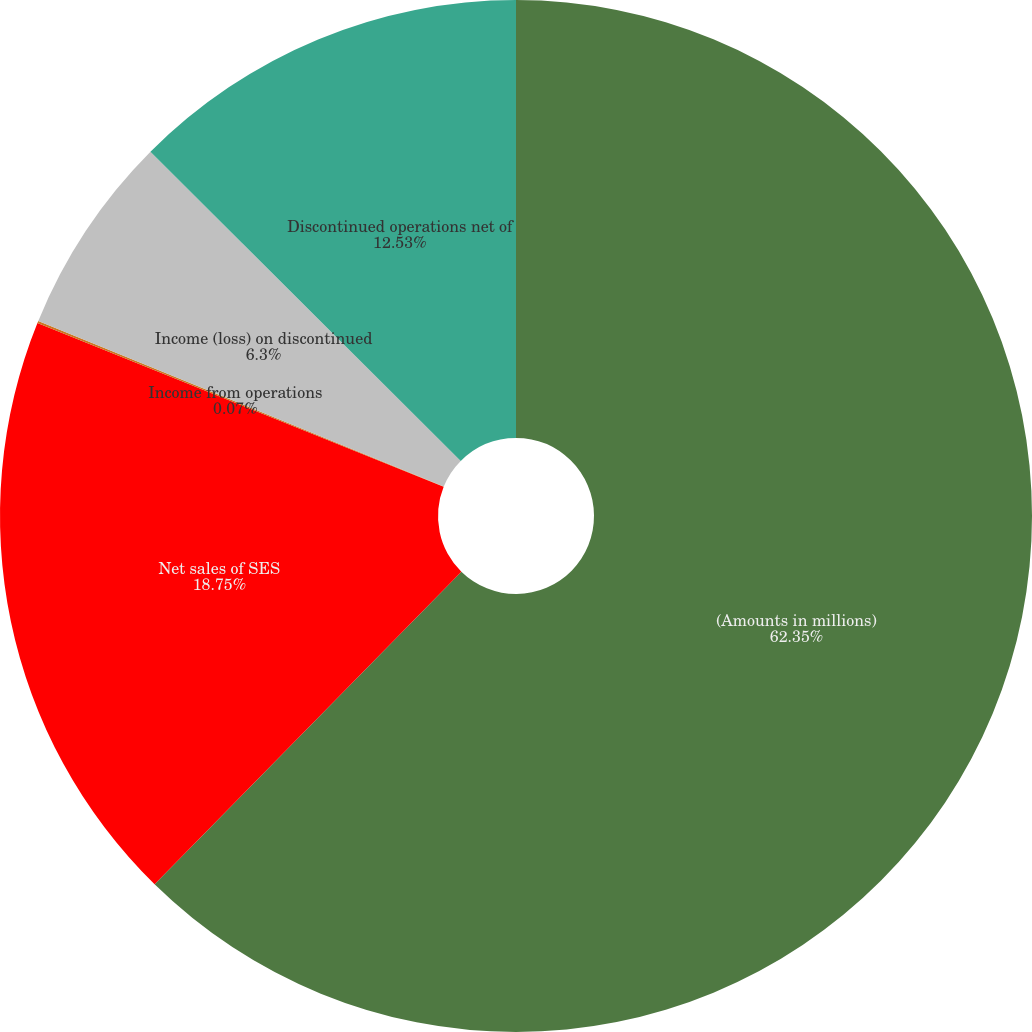Convert chart to OTSL. <chart><loc_0><loc_0><loc_500><loc_500><pie_chart><fcel>(Amounts in millions)<fcel>Net sales of SES<fcel>Income from operations<fcel>Income (loss) on discontinued<fcel>Discontinued operations net of<nl><fcel>62.35%<fcel>18.75%<fcel>0.07%<fcel>6.3%<fcel>12.53%<nl></chart> 